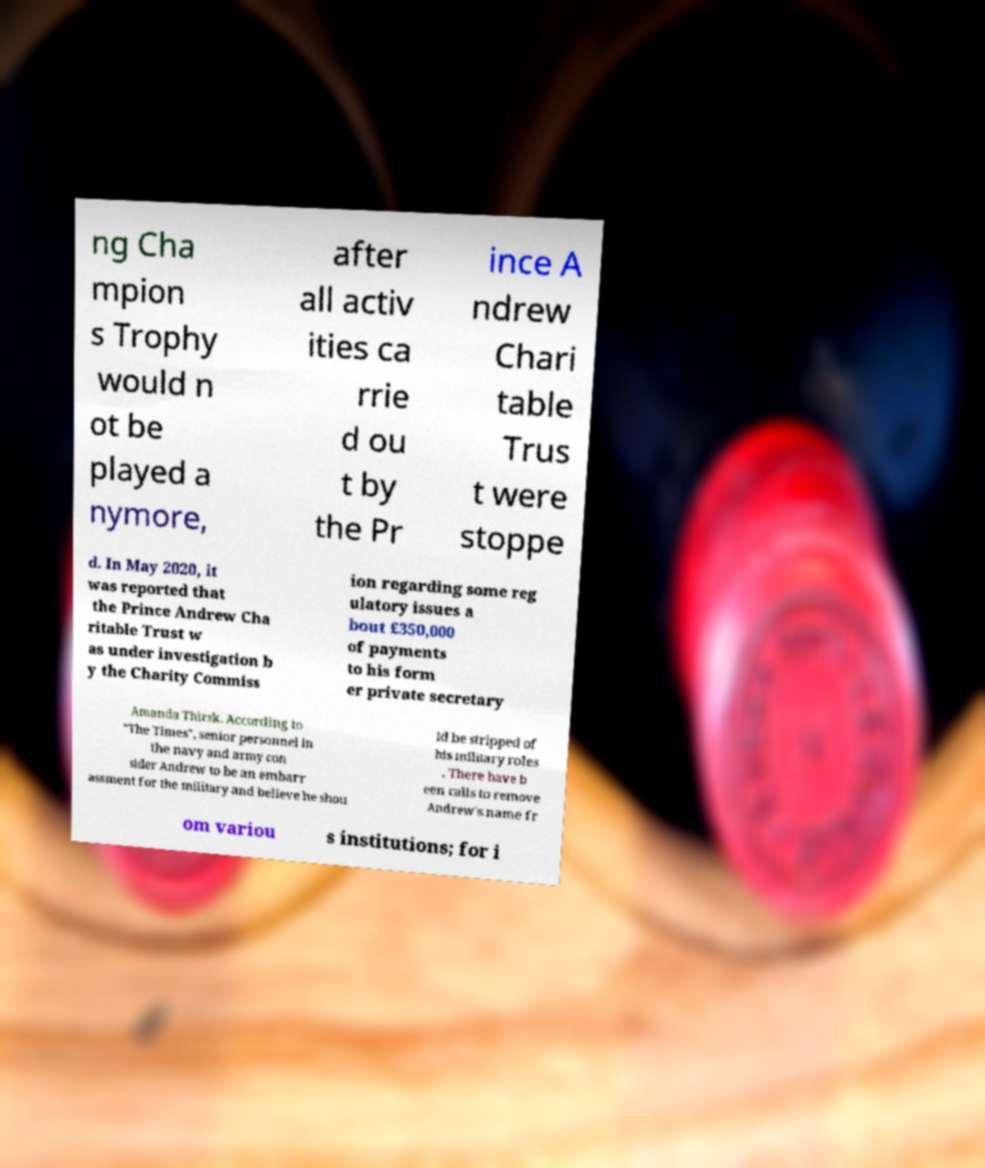Please identify and transcribe the text found in this image. ng Cha mpion s Trophy would n ot be played a nymore, after all activ ities ca rrie d ou t by the Pr ince A ndrew Chari table Trus t were stoppe d. In May 2020, it was reported that the Prince Andrew Cha ritable Trust w as under investigation b y the Charity Commiss ion regarding some reg ulatory issues a bout £350,000 of payments to his form er private secretary Amanda Thirsk. According to "The Times", senior personnel in the navy and army con sider Andrew to be an embarr assment for the military and believe he shou ld be stripped of his military roles . There have b een calls to remove Andrew's name fr om variou s institutions; for i 